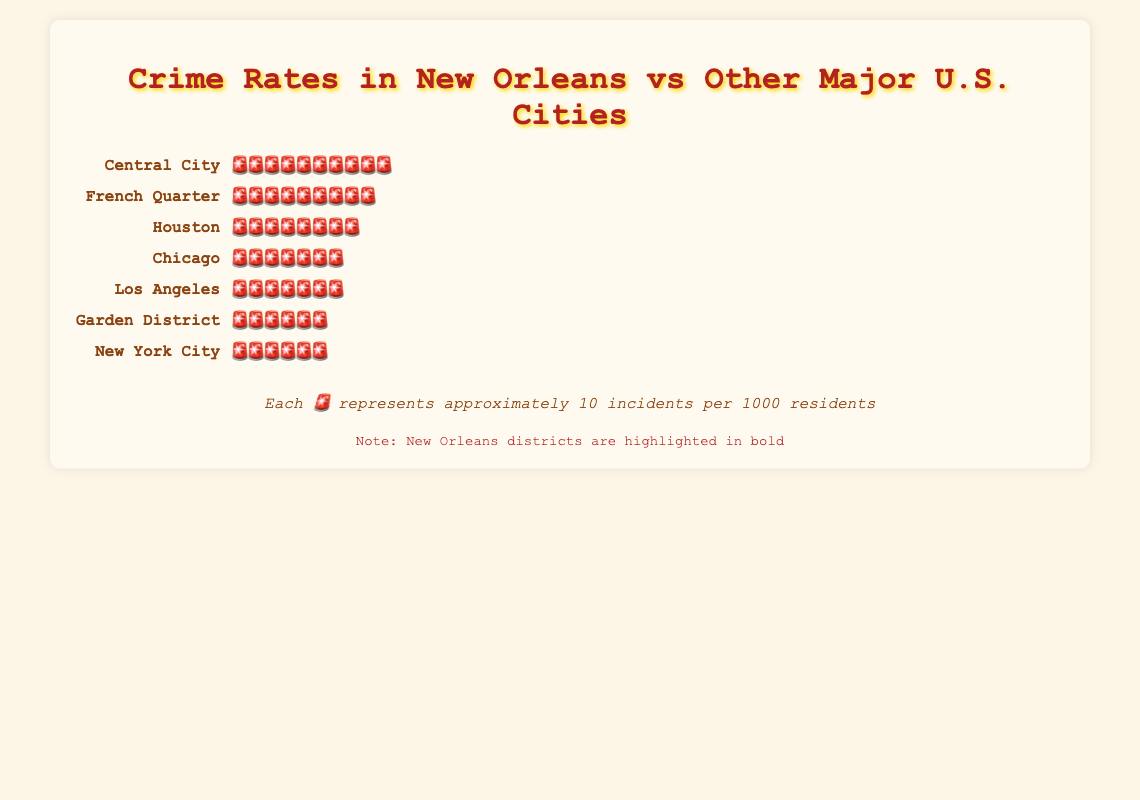What is the crime rate in Central City, New Orleans? Central City in New Orleans has 9 crime icons, with each icon representing approximately 10 incidents per 1000 residents. Therefore, the crime rate is about 9 * 10 = 90 incidents per 1000 residents.
Answer: 90 incidents per 1000 residents Which district in New Orleans has the lowest crime rate? Comparing the crime icons: French Quarter has 8 icons, Garden District has 6 icons, and Central City has 9 icons. The Garden District has the lowest crime rate.
Answer: Garden District How does the crime rate in the French Quarter compare to New York City? French Quarter has 8 icons and New York City has 6 icons. Each icon represents 10 incidents per 1000 residents. Therefore, the crime rate in the French Quarter is higher (80 incidents) compared to New York City (60 incidents).
Answer: French Quarter is higher What’s the average crime rate across the three districts of New Orleans? Calculating the average: French Quarter (8 icons * 10 = 80), Garden District (6 icons * 10 = 60), Central City (9 icons * 10 = 90). Average = (80 + 60 + 90) / 3 = 230 / 3 ≈ 76.67 incidents per 1000 residents.
Answer: ≈ 76.67 incidents per 1000 residents Which city has a higher crime rate, Chicago or Los Angeles? Chicago and Los Angeles each have 7 icons, representing 70 incidents per 1000 residents. Both cities have the same crime rate.
Answer: Equal How many more incidents per 1000 residents are there in Central City compared to the Garden District? Central City has 90 incidents (9 icons * 10) and Garden District has 60 incidents (6 icons * 10). Difference = 90 - 60 = 30 incidents per 1000 residents.
Answer: 30 incidents per 1000 residents What is the total number of crime icons representing all cities and districts combined? Summing up the icons: Central City (9) + French Quarter (8) + Garden District (6) + Houston (8) + Chicago (7) + New York City (6) + Los Angeles (7) = 51 icons.
Answer: 51 icons Which area, New Orleans' Garden District or Los Angeles, has a lower crime rate? Garden District has 6 icons, and Los Angeles has 7 icons. Since fewer icons represent a lower crime rate, Garden District has a lower crime rate.
Answer: Garden District Comparing New Orleans as a whole to Chicago, which has a higher crime rate? Summing up New Orleans' crime icons: Central City (9) + French Quarter (8) + Garden District (6) = 23 icons. Chicago has 7 icons. Even though this isn't completely fair since one is 3 districts and the other is a single city, visually, New Orleans as a whole has more icons than Chicago.
Answer: New Orleans (aggregate) What is the ratio of the crime rate in Houston to the Garden District? Houston has 8 icons (80 incidents) and Garden District has 6 icons (60 incidents). Ratio = 80 / 60 = 4 / 3 or 1.33.
Answer: 1.33 